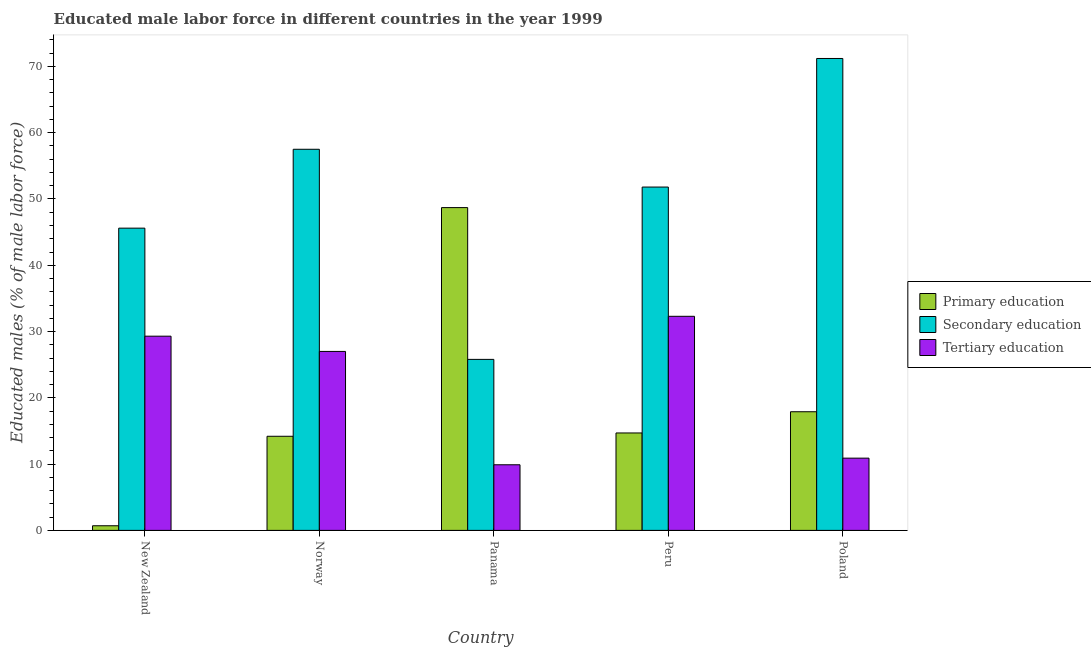How many different coloured bars are there?
Offer a very short reply. 3. Are the number of bars on each tick of the X-axis equal?
Your response must be concise. Yes. How many bars are there on the 5th tick from the right?
Provide a short and direct response. 3. What is the label of the 1st group of bars from the left?
Provide a succinct answer. New Zealand. What is the percentage of male labor force who received secondary education in Poland?
Keep it short and to the point. 71.2. Across all countries, what is the maximum percentage of male labor force who received secondary education?
Your answer should be compact. 71.2. Across all countries, what is the minimum percentage of male labor force who received secondary education?
Offer a terse response. 25.8. In which country was the percentage of male labor force who received primary education maximum?
Provide a succinct answer. Panama. In which country was the percentage of male labor force who received tertiary education minimum?
Keep it short and to the point. Panama. What is the total percentage of male labor force who received secondary education in the graph?
Your answer should be compact. 251.9. What is the difference between the percentage of male labor force who received primary education in Norway and the percentage of male labor force who received tertiary education in Panama?
Provide a short and direct response. 4.3. What is the average percentage of male labor force who received secondary education per country?
Your answer should be compact. 50.38. What is the difference between the percentage of male labor force who received secondary education and percentage of male labor force who received primary education in Poland?
Give a very brief answer. 53.3. What is the ratio of the percentage of male labor force who received primary education in New Zealand to that in Peru?
Your answer should be very brief. 0.05. What is the difference between the highest and the second highest percentage of male labor force who received tertiary education?
Your answer should be compact. 3. What is the difference between the highest and the lowest percentage of male labor force who received secondary education?
Provide a short and direct response. 45.4. What does the 2nd bar from the left in New Zealand represents?
Your answer should be compact. Secondary education. What does the 3rd bar from the right in Panama represents?
Offer a very short reply. Primary education. Is it the case that in every country, the sum of the percentage of male labor force who received primary education and percentage of male labor force who received secondary education is greater than the percentage of male labor force who received tertiary education?
Provide a short and direct response. Yes. Are all the bars in the graph horizontal?
Offer a terse response. No. How many legend labels are there?
Offer a terse response. 3. What is the title of the graph?
Your answer should be very brief. Educated male labor force in different countries in the year 1999. What is the label or title of the Y-axis?
Provide a short and direct response. Educated males (% of male labor force). What is the Educated males (% of male labor force) in Primary education in New Zealand?
Offer a terse response. 0.7. What is the Educated males (% of male labor force) of Secondary education in New Zealand?
Offer a very short reply. 45.6. What is the Educated males (% of male labor force) of Tertiary education in New Zealand?
Your response must be concise. 29.3. What is the Educated males (% of male labor force) in Primary education in Norway?
Keep it short and to the point. 14.2. What is the Educated males (% of male labor force) in Secondary education in Norway?
Make the answer very short. 57.5. What is the Educated males (% of male labor force) of Tertiary education in Norway?
Provide a succinct answer. 27. What is the Educated males (% of male labor force) of Primary education in Panama?
Your response must be concise. 48.7. What is the Educated males (% of male labor force) of Secondary education in Panama?
Your response must be concise. 25.8. What is the Educated males (% of male labor force) in Tertiary education in Panama?
Offer a very short reply. 9.9. What is the Educated males (% of male labor force) in Primary education in Peru?
Your answer should be compact. 14.7. What is the Educated males (% of male labor force) of Secondary education in Peru?
Your answer should be compact. 51.8. What is the Educated males (% of male labor force) of Tertiary education in Peru?
Offer a terse response. 32.3. What is the Educated males (% of male labor force) in Primary education in Poland?
Give a very brief answer. 17.9. What is the Educated males (% of male labor force) of Secondary education in Poland?
Your response must be concise. 71.2. What is the Educated males (% of male labor force) in Tertiary education in Poland?
Offer a terse response. 10.9. Across all countries, what is the maximum Educated males (% of male labor force) in Primary education?
Give a very brief answer. 48.7. Across all countries, what is the maximum Educated males (% of male labor force) of Secondary education?
Your response must be concise. 71.2. Across all countries, what is the maximum Educated males (% of male labor force) of Tertiary education?
Your answer should be very brief. 32.3. Across all countries, what is the minimum Educated males (% of male labor force) of Primary education?
Your response must be concise. 0.7. Across all countries, what is the minimum Educated males (% of male labor force) in Secondary education?
Keep it short and to the point. 25.8. Across all countries, what is the minimum Educated males (% of male labor force) of Tertiary education?
Provide a succinct answer. 9.9. What is the total Educated males (% of male labor force) of Primary education in the graph?
Keep it short and to the point. 96.2. What is the total Educated males (% of male labor force) of Secondary education in the graph?
Keep it short and to the point. 251.9. What is the total Educated males (% of male labor force) in Tertiary education in the graph?
Your answer should be very brief. 109.4. What is the difference between the Educated males (% of male labor force) of Secondary education in New Zealand and that in Norway?
Keep it short and to the point. -11.9. What is the difference between the Educated males (% of male labor force) of Primary education in New Zealand and that in Panama?
Provide a succinct answer. -48. What is the difference between the Educated males (% of male labor force) of Secondary education in New Zealand and that in Panama?
Provide a succinct answer. 19.8. What is the difference between the Educated males (% of male labor force) of Tertiary education in New Zealand and that in Panama?
Provide a short and direct response. 19.4. What is the difference between the Educated males (% of male labor force) in Primary education in New Zealand and that in Peru?
Your response must be concise. -14. What is the difference between the Educated males (% of male labor force) in Secondary education in New Zealand and that in Peru?
Keep it short and to the point. -6.2. What is the difference between the Educated males (% of male labor force) in Primary education in New Zealand and that in Poland?
Provide a succinct answer. -17.2. What is the difference between the Educated males (% of male labor force) of Secondary education in New Zealand and that in Poland?
Offer a very short reply. -25.6. What is the difference between the Educated males (% of male labor force) in Tertiary education in New Zealand and that in Poland?
Provide a succinct answer. 18.4. What is the difference between the Educated males (% of male labor force) of Primary education in Norway and that in Panama?
Your answer should be compact. -34.5. What is the difference between the Educated males (% of male labor force) in Secondary education in Norway and that in Panama?
Give a very brief answer. 31.7. What is the difference between the Educated males (% of male labor force) in Secondary education in Norway and that in Peru?
Offer a terse response. 5.7. What is the difference between the Educated males (% of male labor force) of Tertiary education in Norway and that in Peru?
Your response must be concise. -5.3. What is the difference between the Educated males (% of male labor force) in Secondary education in Norway and that in Poland?
Your answer should be compact. -13.7. What is the difference between the Educated males (% of male labor force) in Primary education in Panama and that in Peru?
Provide a short and direct response. 34. What is the difference between the Educated males (% of male labor force) of Secondary education in Panama and that in Peru?
Offer a terse response. -26. What is the difference between the Educated males (% of male labor force) of Tertiary education in Panama and that in Peru?
Make the answer very short. -22.4. What is the difference between the Educated males (% of male labor force) in Primary education in Panama and that in Poland?
Give a very brief answer. 30.8. What is the difference between the Educated males (% of male labor force) of Secondary education in Panama and that in Poland?
Provide a short and direct response. -45.4. What is the difference between the Educated males (% of male labor force) of Secondary education in Peru and that in Poland?
Make the answer very short. -19.4. What is the difference between the Educated males (% of male labor force) in Tertiary education in Peru and that in Poland?
Make the answer very short. 21.4. What is the difference between the Educated males (% of male labor force) of Primary education in New Zealand and the Educated males (% of male labor force) of Secondary education in Norway?
Give a very brief answer. -56.8. What is the difference between the Educated males (% of male labor force) of Primary education in New Zealand and the Educated males (% of male labor force) of Tertiary education in Norway?
Your answer should be compact. -26.3. What is the difference between the Educated males (% of male labor force) in Primary education in New Zealand and the Educated males (% of male labor force) in Secondary education in Panama?
Your response must be concise. -25.1. What is the difference between the Educated males (% of male labor force) in Primary education in New Zealand and the Educated males (% of male labor force) in Tertiary education in Panama?
Provide a succinct answer. -9.2. What is the difference between the Educated males (% of male labor force) of Secondary education in New Zealand and the Educated males (% of male labor force) of Tertiary education in Panama?
Provide a succinct answer. 35.7. What is the difference between the Educated males (% of male labor force) of Primary education in New Zealand and the Educated males (% of male labor force) of Secondary education in Peru?
Your answer should be very brief. -51.1. What is the difference between the Educated males (% of male labor force) of Primary education in New Zealand and the Educated males (% of male labor force) of Tertiary education in Peru?
Offer a very short reply. -31.6. What is the difference between the Educated males (% of male labor force) in Primary education in New Zealand and the Educated males (% of male labor force) in Secondary education in Poland?
Your answer should be compact. -70.5. What is the difference between the Educated males (% of male labor force) of Secondary education in New Zealand and the Educated males (% of male labor force) of Tertiary education in Poland?
Provide a succinct answer. 34.7. What is the difference between the Educated males (% of male labor force) of Primary education in Norway and the Educated males (% of male labor force) of Secondary education in Panama?
Offer a terse response. -11.6. What is the difference between the Educated males (% of male labor force) of Secondary education in Norway and the Educated males (% of male labor force) of Tertiary education in Panama?
Offer a terse response. 47.6. What is the difference between the Educated males (% of male labor force) in Primary education in Norway and the Educated males (% of male labor force) in Secondary education in Peru?
Your answer should be very brief. -37.6. What is the difference between the Educated males (% of male labor force) in Primary education in Norway and the Educated males (% of male labor force) in Tertiary education in Peru?
Keep it short and to the point. -18.1. What is the difference between the Educated males (% of male labor force) in Secondary education in Norway and the Educated males (% of male labor force) in Tertiary education in Peru?
Your answer should be compact. 25.2. What is the difference between the Educated males (% of male labor force) in Primary education in Norway and the Educated males (% of male labor force) in Secondary education in Poland?
Provide a succinct answer. -57. What is the difference between the Educated males (% of male labor force) of Primary education in Norway and the Educated males (% of male labor force) of Tertiary education in Poland?
Your response must be concise. 3.3. What is the difference between the Educated males (% of male labor force) in Secondary education in Norway and the Educated males (% of male labor force) in Tertiary education in Poland?
Give a very brief answer. 46.6. What is the difference between the Educated males (% of male labor force) in Primary education in Panama and the Educated males (% of male labor force) in Secondary education in Poland?
Your answer should be compact. -22.5. What is the difference between the Educated males (% of male labor force) in Primary education in Panama and the Educated males (% of male labor force) in Tertiary education in Poland?
Ensure brevity in your answer.  37.8. What is the difference between the Educated males (% of male labor force) in Primary education in Peru and the Educated males (% of male labor force) in Secondary education in Poland?
Your answer should be compact. -56.5. What is the difference between the Educated males (% of male labor force) in Primary education in Peru and the Educated males (% of male labor force) in Tertiary education in Poland?
Provide a short and direct response. 3.8. What is the difference between the Educated males (% of male labor force) of Secondary education in Peru and the Educated males (% of male labor force) of Tertiary education in Poland?
Make the answer very short. 40.9. What is the average Educated males (% of male labor force) in Primary education per country?
Offer a very short reply. 19.24. What is the average Educated males (% of male labor force) of Secondary education per country?
Your answer should be compact. 50.38. What is the average Educated males (% of male labor force) in Tertiary education per country?
Ensure brevity in your answer.  21.88. What is the difference between the Educated males (% of male labor force) of Primary education and Educated males (% of male labor force) of Secondary education in New Zealand?
Offer a very short reply. -44.9. What is the difference between the Educated males (% of male labor force) in Primary education and Educated males (% of male labor force) in Tertiary education in New Zealand?
Your answer should be compact. -28.6. What is the difference between the Educated males (% of male labor force) of Primary education and Educated males (% of male labor force) of Secondary education in Norway?
Keep it short and to the point. -43.3. What is the difference between the Educated males (% of male labor force) in Secondary education and Educated males (% of male labor force) in Tertiary education in Norway?
Ensure brevity in your answer.  30.5. What is the difference between the Educated males (% of male labor force) in Primary education and Educated males (% of male labor force) in Secondary education in Panama?
Make the answer very short. 22.9. What is the difference between the Educated males (% of male labor force) in Primary education and Educated males (% of male labor force) in Tertiary education in Panama?
Offer a terse response. 38.8. What is the difference between the Educated males (% of male labor force) in Secondary education and Educated males (% of male labor force) in Tertiary education in Panama?
Offer a terse response. 15.9. What is the difference between the Educated males (% of male labor force) in Primary education and Educated males (% of male labor force) in Secondary education in Peru?
Keep it short and to the point. -37.1. What is the difference between the Educated males (% of male labor force) in Primary education and Educated males (% of male labor force) in Tertiary education in Peru?
Your answer should be compact. -17.6. What is the difference between the Educated males (% of male labor force) of Primary education and Educated males (% of male labor force) of Secondary education in Poland?
Your answer should be very brief. -53.3. What is the difference between the Educated males (% of male labor force) of Secondary education and Educated males (% of male labor force) of Tertiary education in Poland?
Your response must be concise. 60.3. What is the ratio of the Educated males (% of male labor force) in Primary education in New Zealand to that in Norway?
Your answer should be very brief. 0.05. What is the ratio of the Educated males (% of male labor force) of Secondary education in New Zealand to that in Norway?
Your answer should be very brief. 0.79. What is the ratio of the Educated males (% of male labor force) in Tertiary education in New Zealand to that in Norway?
Make the answer very short. 1.09. What is the ratio of the Educated males (% of male labor force) in Primary education in New Zealand to that in Panama?
Keep it short and to the point. 0.01. What is the ratio of the Educated males (% of male labor force) of Secondary education in New Zealand to that in Panama?
Give a very brief answer. 1.77. What is the ratio of the Educated males (% of male labor force) in Tertiary education in New Zealand to that in Panama?
Provide a short and direct response. 2.96. What is the ratio of the Educated males (% of male labor force) in Primary education in New Zealand to that in Peru?
Give a very brief answer. 0.05. What is the ratio of the Educated males (% of male labor force) in Secondary education in New Zealand to that in Peru?
Offer a very short reply. 0.88. What is the ratio of the Educated males (% of male labor force) of Tertiary education in New Zealand to that in Peru?
Offer a very short reply. 0.91. What is the ratio of the Educated males (% of male labor force) in Primary education in New Zealand to that in Poland?
Provide a succinct answer. 0.04. What is the ratio of the Educated males (% of male labor force) of Secondary education in New Zealand to that in Poland?
Offer a terse response. 0.64. What is the ratio of the Educated males (% of male labor force) in Tertiary education in New Zealand to that in Poland?
Provide a short and direct response. 2.69. What is the ratio of the Educated males (% of male labor force) in Primary education in Norway to that in Panama?
Ensure brevity in your answer.  0.29. What is the ratio of the Educated males (% of male labor force) in Secondary education in Norway to that in Panama?
Offer a very short reply. 2.23. What is the ratio of the Educated males (% of male labor force) of Tertiary education in Norway to that in Panama?
Keep it short and to the point. 2.73. What is the ratio of the Educated males (% of male labor force) of Secondary education in Norway to that in Peru?
Your answer should be very brief. 1.11. What is the ratio of the Educated males (% of male labor force) in Tertiary education in Norway to that in Peru?
Keep it short and to the point. 0.84. What is the ratio of the Educated males (% of male labor force) in Primary education in Norway to that in Poland?
Offer a terse response. 0.79. What is the ratio of the Educated males (% of male labor force) in Secondary education in Norway to that in Poland?
Provide a succinct answer. 0.81. What is the ratio of the Educated males (% of male labor force) in Tertiary education in Norway to that in Poland?
Offer a very short reply. 2.48. What is the ratio of the Educated males (% of male labor force) of Primary education in Panama to that in Peru?
Give a very brief answer. 3.31. What is the ratio of the Educated males (% of male labor force) of Secondary education in Panama to that in Peru?
Offer a terse response. 0.5. What is the ratio of the Educated males (% of male labor force) of Tertiary education in Panama to that in Peru?
Keep it short and to the point. 0.31. What is the ratio of the Educated males (% of male labor force) of Primary education in Panama to that in Poland?
Ensure brevity in your answer.  2.72. What is the ratio of the Educated males (% of male labor force) of Secondary education in Panama to that in Poland?
Keep it short and to the point. 0.36. What is the ratio of the Educated males (% of male labor force) of Tertiary education in Panama to that in Poland?
Your answer should be very brief. 0.91. What is the ratio of the Educated males (% of male labor force) in Primary education in Peru to that in Poland?
Ensure brevity in your answer.  0.82. What is the ratio of the Educated males (% of male labor force) in Secondary education in Peru to that in Poland?
Make the answer very short. 0.73. What is the ratio of the Educated males (% of male labor force) in Tertiary education in Peru to that in Poland?
Provide a short and direct response. 2.96. What is the difference between the highest and the second highest Educated males (% of male labor force) of Primary education?
Your answer should be compact. 30.8. What is the difference between the highest and the second highest Educated males (% of male labor force) of Secondary education?
Ensure brevity in your answer.  13.7. What is the difference between the highest and the lowest Educated males (% of male labor force) in Secondary education?
Provide a short and direct response. 45.4. What is the difference between the highest and the lowest Educated males (% of male labor force) of Tertiary education?
Give a very brief answer. 22.4. 